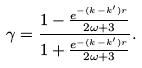Convert formula to latex. <formula><loc_0><loc_0><loc_500><loc_500>\gamma = \frac { 1 - \frac { e ^ { - ( k - k ^ { \prime } ) r } } { 2 \omega + 3 } } { 1 + \frac { e ^ { - ( k - k ^ { \prime } ) r } } { 2 \omega + 3 } } .</formula> 